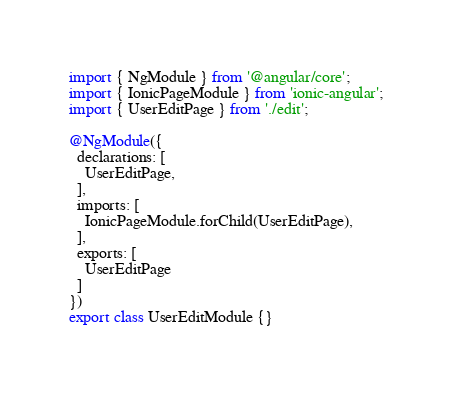<code> <loc_0><loc_0><loc_500><loc_500><_TypeScript_>import { NgModule } from '@angular/core';
import { IonicPageModule } from 'ionic-angular';
import { UserEditPage } from './edit';

@NgModule({
  declarations: [
    UserEditPage,
  ],
  imports: [
    IonicPageModule.forChild(UserEditPage),
  ],
  exports: [
    UserEditPage
  ]
})
export class UserEditModule {}
</code> 